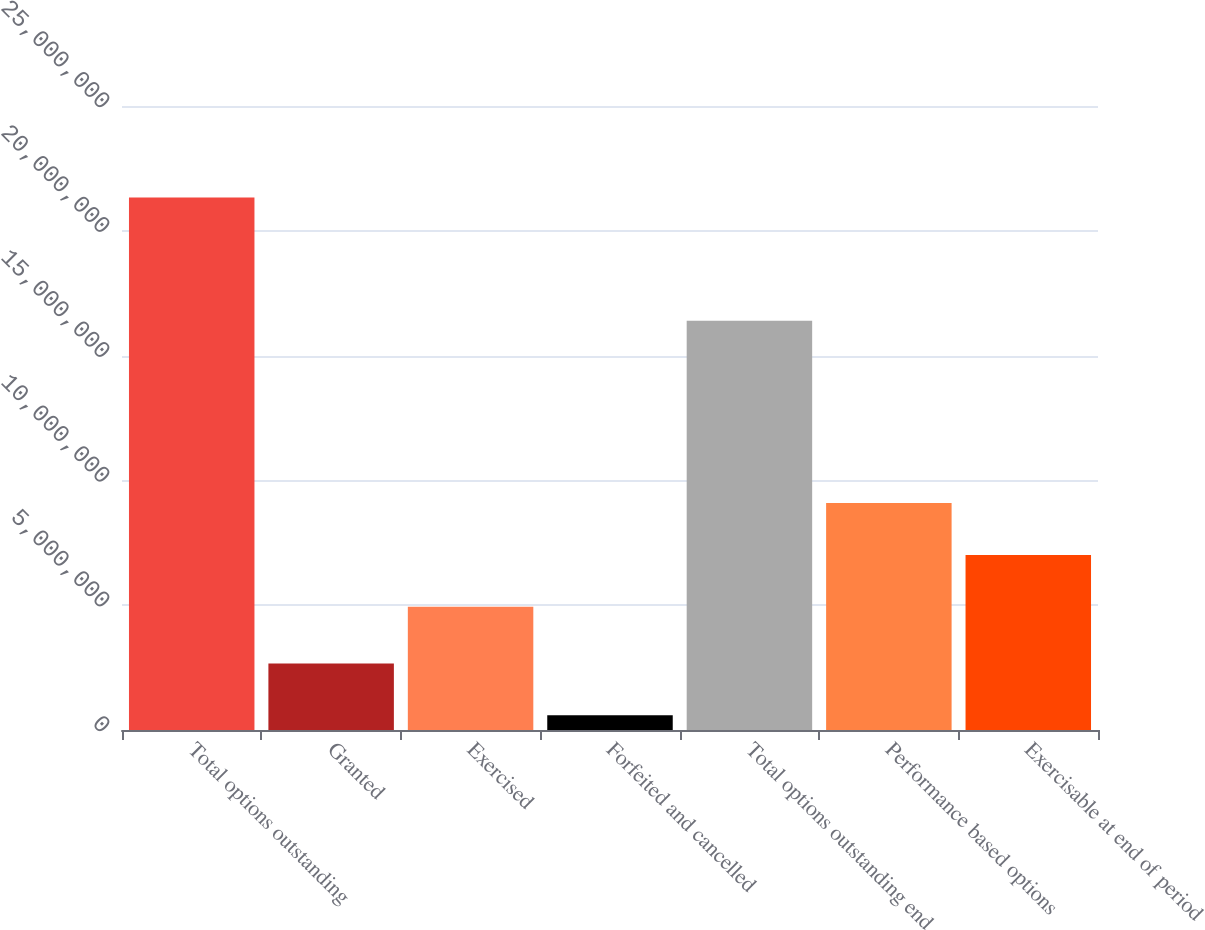<chart> <loc_0><loc_0><loc_500><loc_500><bar_chart><fcel>Total options outstanding<fcel>Granted<fcel>Exercised<fcel>Forfeited and cancelled<fcel>Total options outstanding end<fcel>Performance based options<fcel>Exercisable at end of period<nl><fcel>2.13362e+07<fcel>2.66227e+06<fcel>4.94039e+06<fcel>587396<fcel>1.63999e+07<fcel>9.09015e+06<fcel>7.01527e+06<nl></chart> 